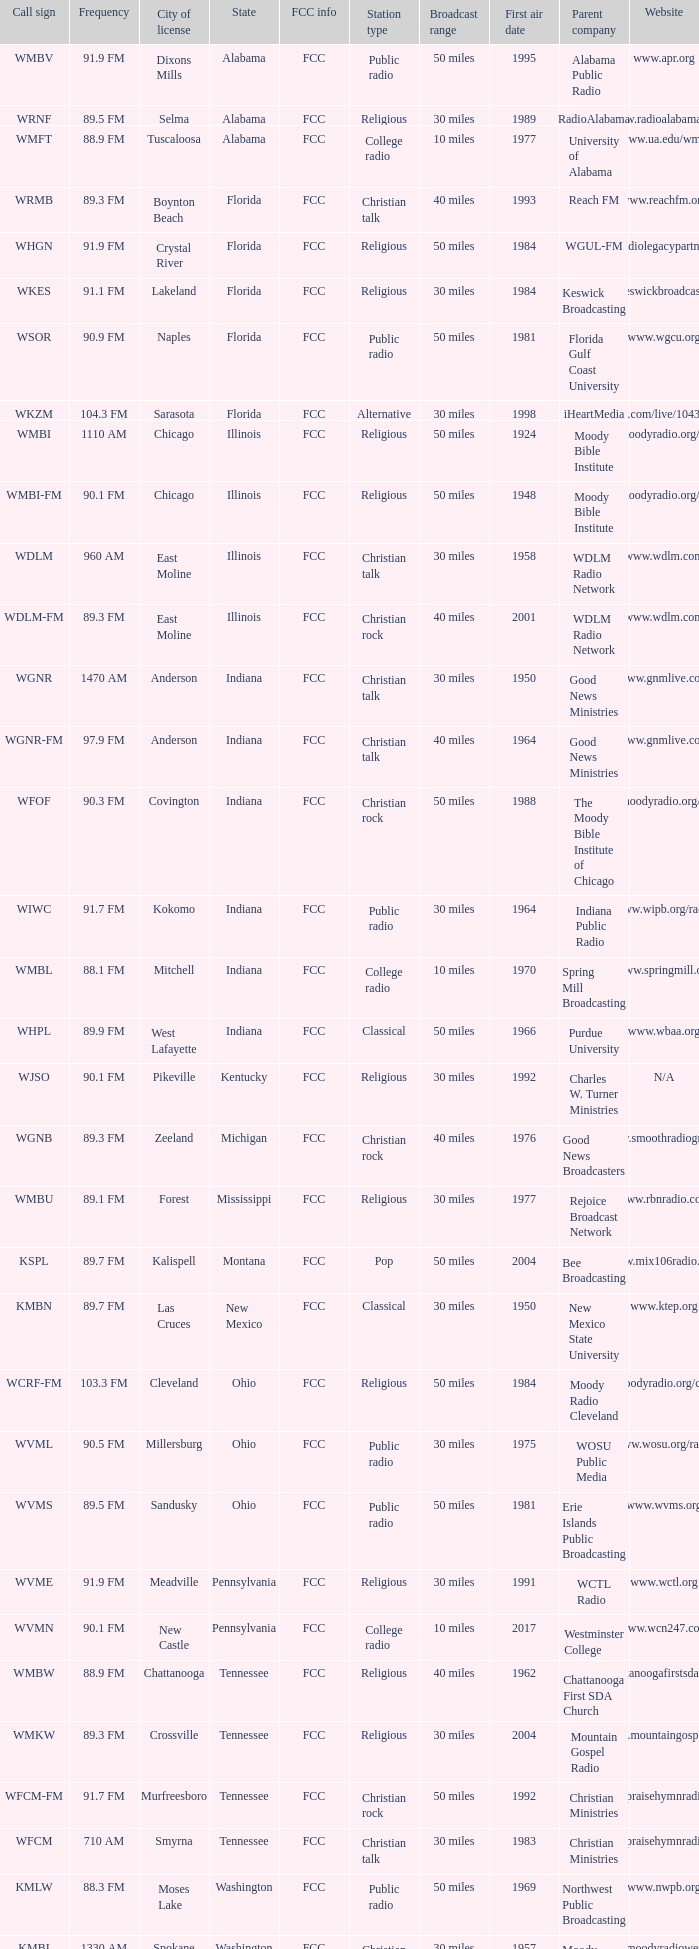What state is the radio station in that has a frequency of 90.1 FM and a city license in New Castle? Pennsylvania. 